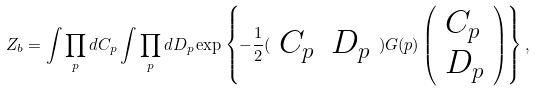<formula> <loc_0><loc_0><loc_500><loc_500>Z _ { b } = \int \prod _ { p } d C _ { p } \int \prod _ { p } d D _ { p } \exp \left \{ - \frac { 1 } { 2 } ( \begin{array} { l l } C _ { p } & D _ { p } \end{array} ) G ( p ) \left ( \begin{array} { l } C _ { p } \\ D _ { p } \end{array} \right ) \right \} ,</formula> 